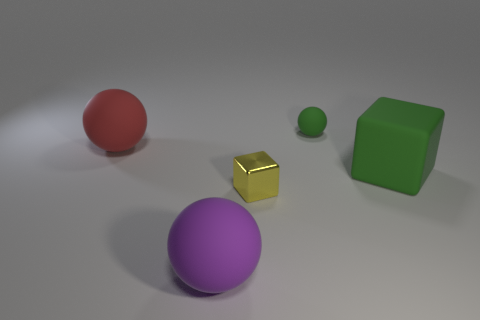Is the big rubber cube the same color as the tiny rubber thing?
Offer a very short reply. Yes. There is a matte cube; is its color the same as the small thing that is behind the green rubber cube?
Make the answer very short. Yes. What is the large block made of?
Give a very brief answer. Rubber. There is a object that is in front of the tiny yellow metallic object; what color is it?
Your answer should be very brief. Purple. How many rubber objects are the same color as the tiny metal block?
Give a very brief answer. 0. What number of spheres are both on the left side of the big purple rubber object and to the right of the red matte ball?
Ensure brevity in your answer.  0. There is a green object that is the same size as the red object; what is its shape?
Your response must be concise. Cube. How big is the purple thing?
Keep it short and to the point. Large. What material is the tiny object in front of the big matte thing left of the sphere that is in front of the tiny yellow block made of?
Offer a terse response. Metal. The small object that is made of the same material as the green block is what color?
Keep it short and to the point. Green. 